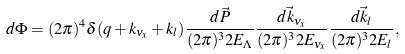Convert formula to latex. <formula><loc_0><loc_0><loc_500><loc_500>d \Phi = ( 2 \pi ) ^ { 4 } \delta ( q + k _ { \nu _ { x } } + k _ { l } ) \frac { d \vec { P } } { ( 2 \pi ) ^ { 3 } 2 E _ { \Lambda } } \frac { d \vec { k } _ { \nu _ { x } } } { ( 2 \pi ) ^ { 3 } 2 E _ { \nu _ { x } } } \frac { d \vec { k } _ { l } } { ( 2 \pi ) ^ { 3 } 2 E _ { l } } ,</formula> 